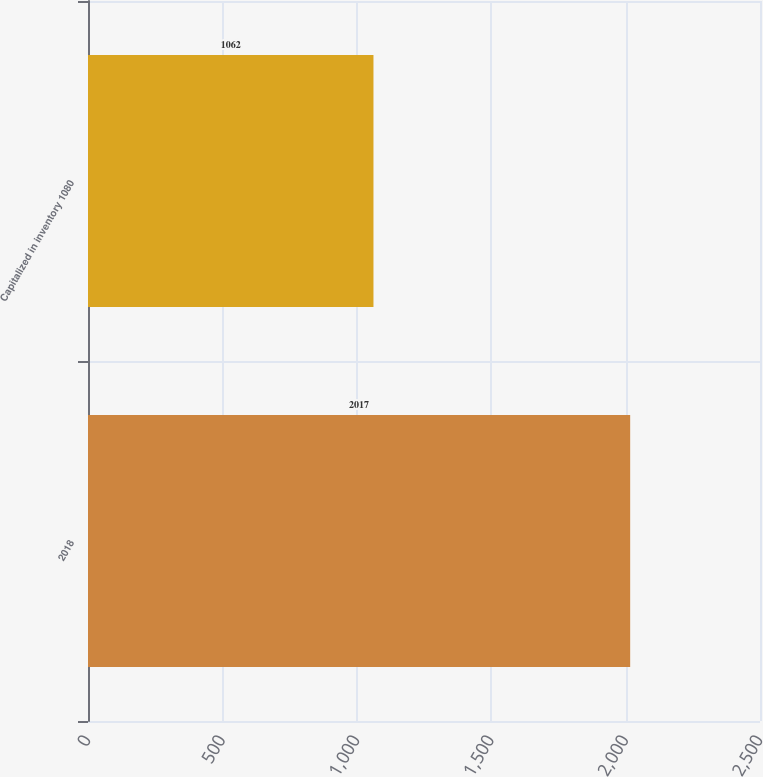<chart> <loc_0><loc_0><loc_500><loc_500><bar_chart><fcel>2018<fcel>Capitalized in inventory 1080<nl><fcel>2017<fcel>1062<nl></chart> 